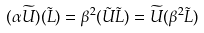<formula> <loc_0><loc_0><loc_500><loc_500>( \alpha \widetilde { U } ) ( \tilde { L } ) = \beta ^ { 2 } ( \tilde { U } \tilde { L } ) = \widetilde { U } ( \beta ^ { 2 } \tilde { L } )</formula> 